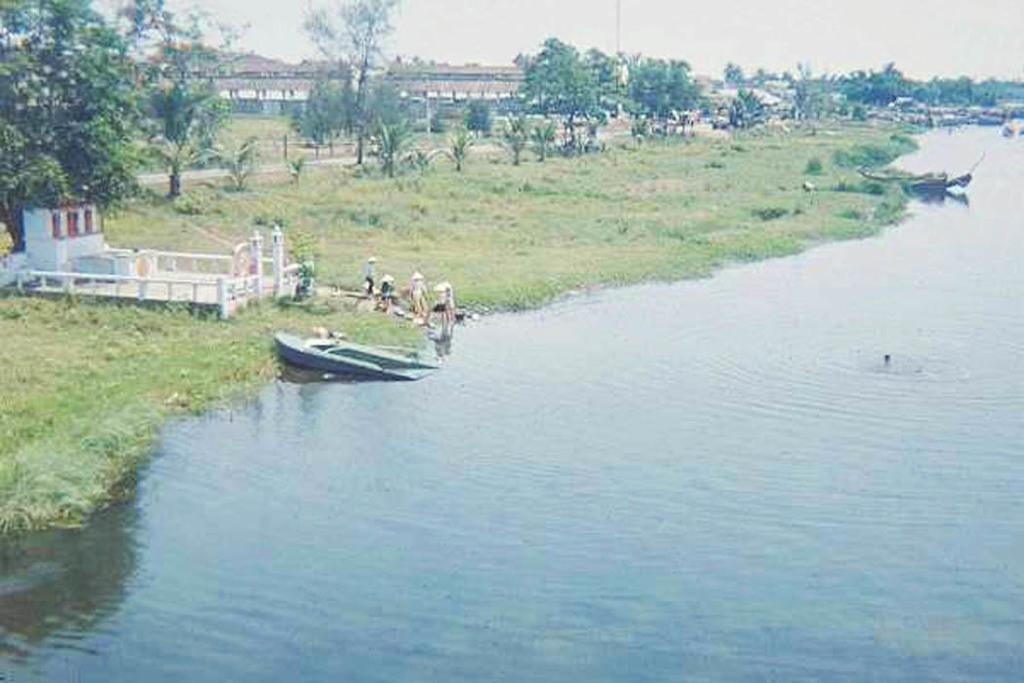Describe this image in one or two sentences. On the right side there is a river. Near to the river there is a boat. And there are few people. On the ground there is grass. Also there are trees. In the back there is a building and sky. On the left side there is a small shed with railings. 